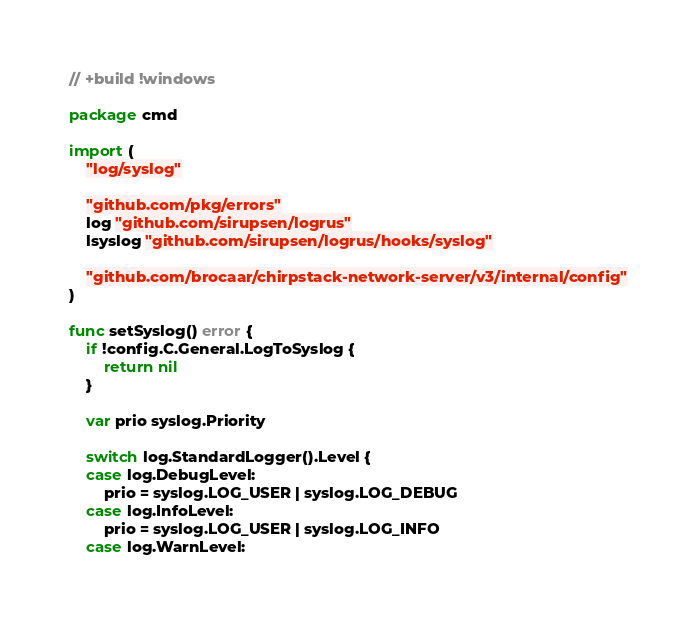<code> <loc_0><loc_0><loc_500><loc_500><_Go_>// +build !windows

package cmd

import (
	"log/syslog"

	"github.com/pkg/errors"
	log "github.com/sirupsen/logrus"
	lsyslog "github.com/sirupsen/logrus/hooks/syslog"

	"github.com/brocaar/chirpstack-network-server/v3/internal/config"
)

func setSyslog() error {
	if !config.C.General.LogToSyslog {
		return nil
	}

	var prio syslog.Priority

	switch log.StandardLogger().Level {
	case log.DebugLevel:
		prio = syslog.LOG_USER | syslog.LOG_DEBUG
	case log.InfoLevel:
		prio = syslog.LOG_USER | syslog.LOG_INFO
	case log.WarnLevel:</code> 